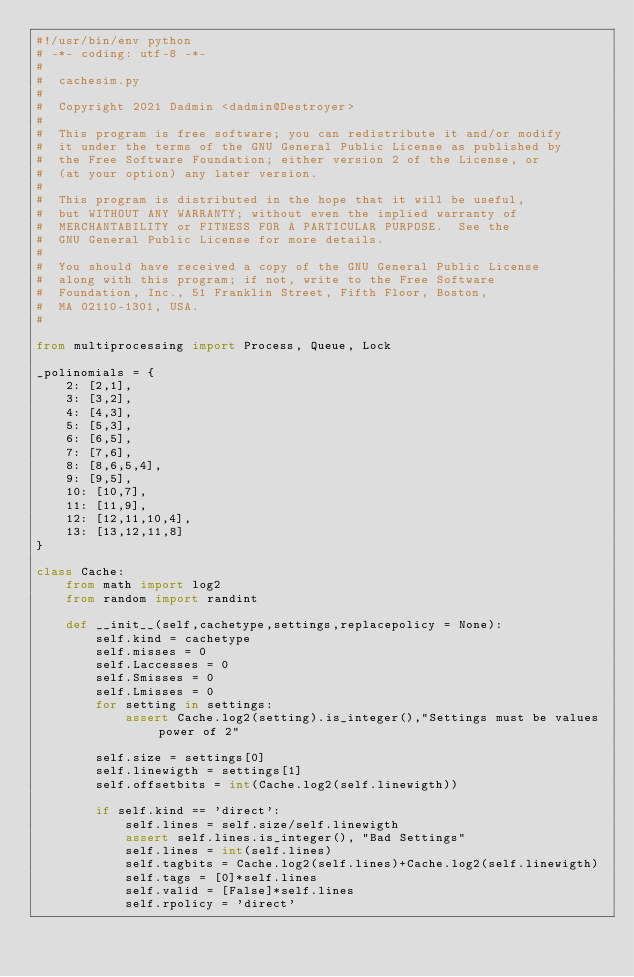<code> <loc_0><loc_0><loc_500><loc_500><_Python_>#!/usr/bin/env python
# -*- coding: utf-8 -*-
#
#  cachesim.py
#  
#  Copyright 2021 Dadmin <dadmin@Destroyer>
#  
#  This program is free software; you can redistribute it and/or modify
#  it under the terms of the GNU General Public License as published by
#  the Free Software Foundation; either version 2 of the License, or
#  (at your option) any later version.
#  
#  This program is distributed in the hope that it will be useful,
#  but WITHOUT ANY WARRANTY; without even the implied warranty of
#  MERCHANTABILITY or FITNESS FOR A PARTICULAR PURPOSE.  See the
#  GNU General Public License for more details.
#  
#  You should have received a copy of the GNU General Public License
#  along with this program; if not, write to the Free Software
#  Foundation, Inc., 51 Franklin Street, Fifth Floor, Boston,
#  MA 02110-1301, USA.
#  

from multiprocessing import Process, Queue, Lock

_polinomials = {
    2: [2,1],
    3: [3,2],
    4: [4,3],
    5: [5,3],
    6: [6,5],
    7: [7,6],
    8: [8,6,5,4],
    9: [9,5],
    10: [10,7],
    11: [11,9],
    12: [12,11,10,4],
    13: [13,12,11,8]
}

class Cache:
	from math import log2
	from random import randint
	
	def __init__(self,cachetype,settings,replacepolicy = None):
		self.kind = cachetype
		self.misses = 0
		self.Laccesses = 0
		self.Smisses = 0
		self.Lmisses = 0
		for setting in settings:
			assert Cache.log2(setting).is_integer(),"Settings must be values power of 2"
		
		self.size = settings[0]
		self.linewigth = settings[1]
		self.offsetbits = int(Cache.log2(self.linewigth))
		
		if self.kind == 'direct':
			self.lines = self.size/self.linewigth
			assert self.lines.is_integer(), "Bad Settings"
			self.lines = int(self.lines)
			self.tagbits = Cache.log2(self.lines)+Cache.log2(self.linewigth)
			self.tags = [0]*self.lines 
			self.valid = [False]*self.lines
			self.rpolicy = 'direct'
			</code> 